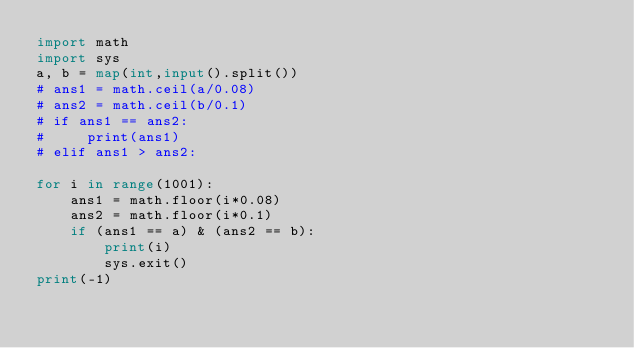Convert code to text. <code><loc_0><loc_0><loc_500><loc_500><_Python_>import math
import sys 
a, b = map(int,input().split())
# ans1 = math.ceil(a/0.08)
# ans2 = math.ceil(b/0.1)
# if ans1 == ans2:
#     print(ans1)
# elif ans1 > ans2:

for i in range(1001):
    ans1 = math.floor(i*0.08)
    ans2 = math.floor(i*0.1)
    if (ans1 == a) & (ans2 == b):
        print(i)
        sys.exit()
print(-1)
</code> 